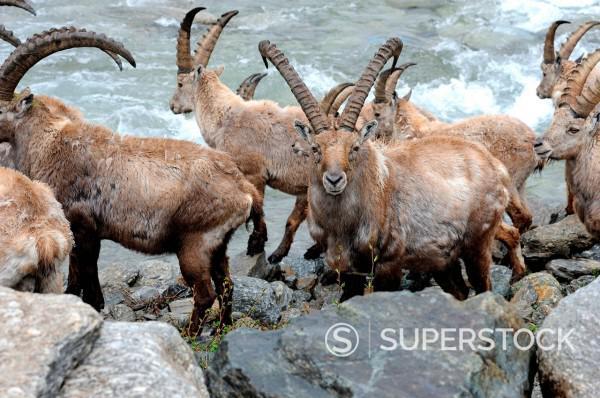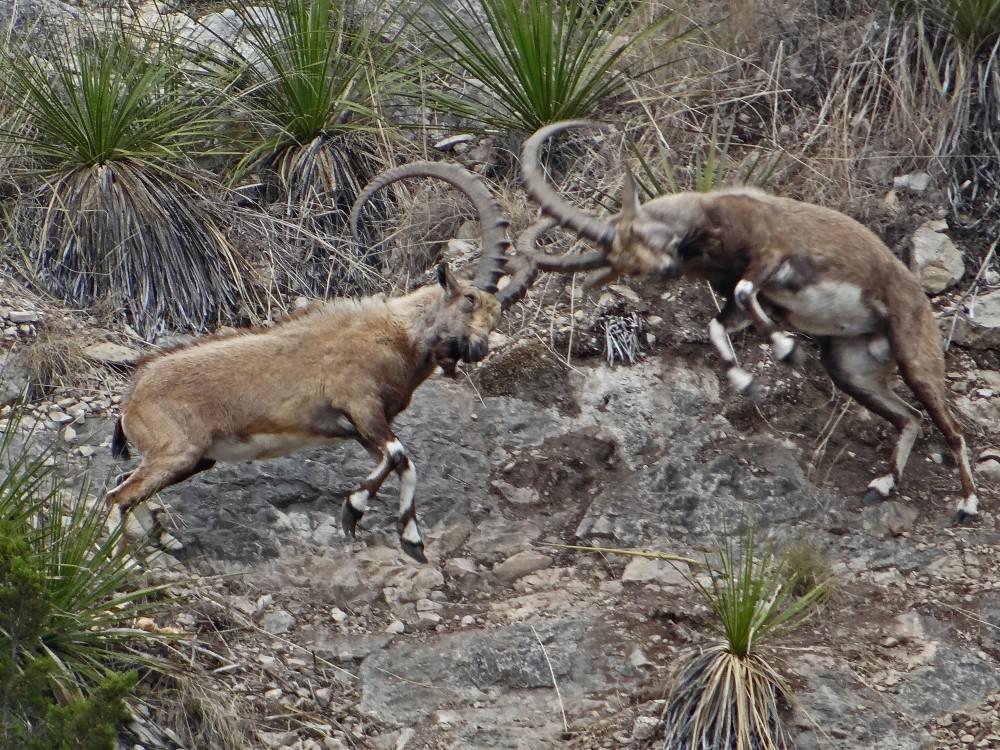The first image is the image on the left, the second image is the image on the right. For the images shown, is this caption "the animal on the right image is facing left" true? Answer yes or no. No. 